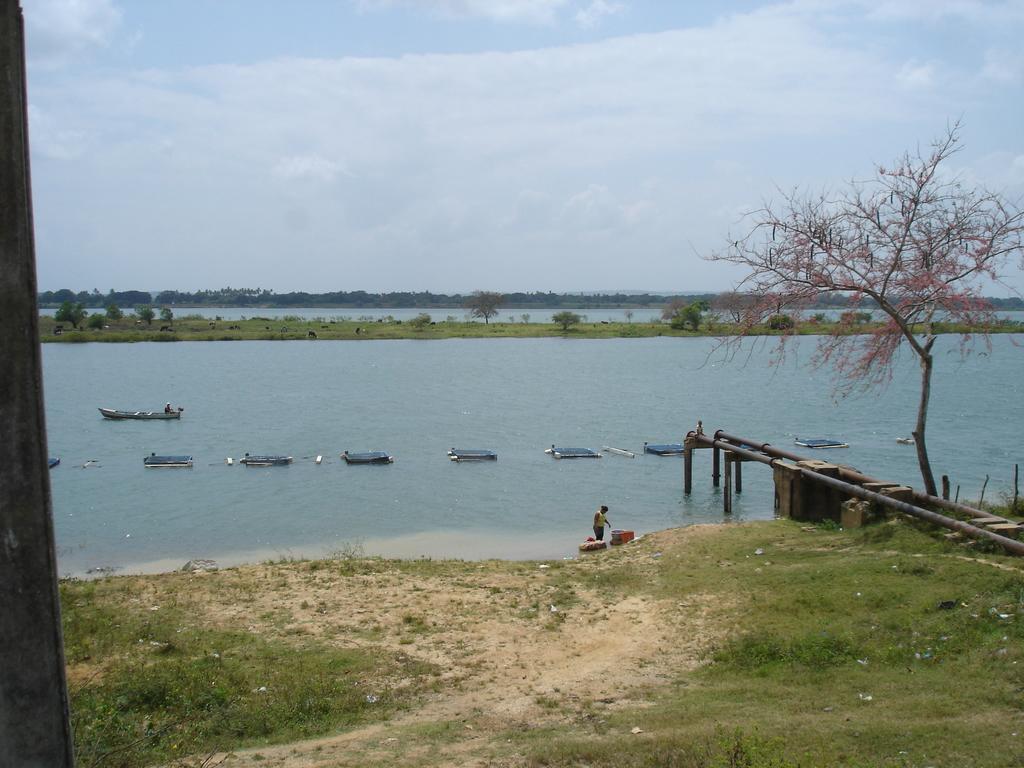In one or two sentences, can you explain what this image depicts? In this image in the center there is one sea, and in the sea there are some ships. At the bottom there is grass and sand, and on the right side there is a bridge, trees. And in the background there are some trees, at the top of the image there is sky and on the right side there is some stick. 